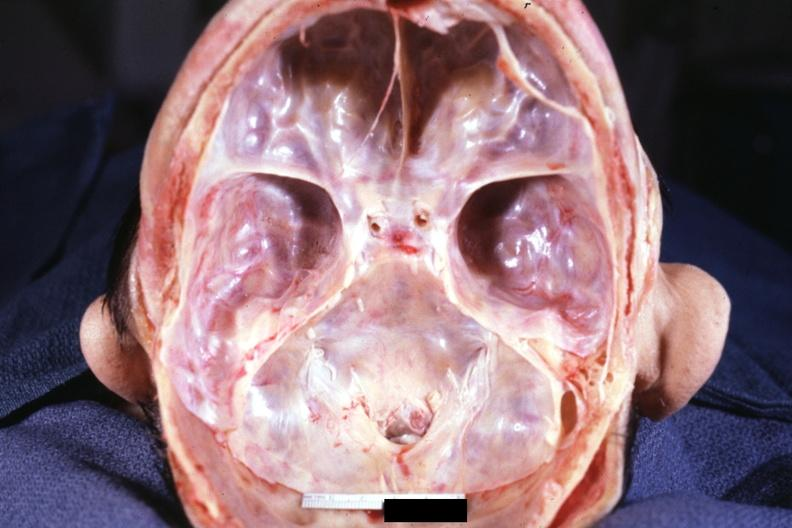what is present?
Answer the question using a single word or phrase. Bone 